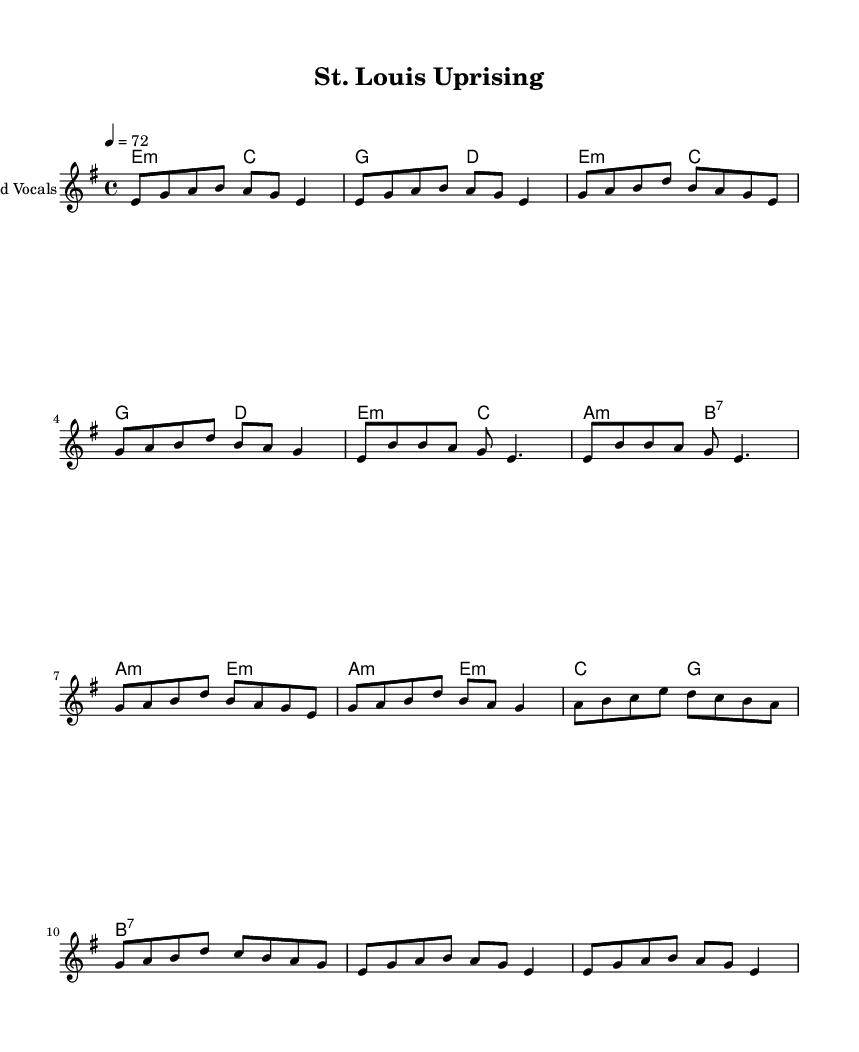What is the key signature of this music? The key signature is E minor, which has one sharp (F#) and is indicated at the beginning of the staff.
Answer: E minor What is the time signature of this music? The time signature is 4/4, meaning there are four beats per measure, indicated at the beginning of the score.
Answer: 4/4 What is the tempo of the piece? The tempo is marked as 72 beats per minute, which is indicated within the score after the time signature.
Answer: 72 How many measures are there in the verse section? The verse section contains four measures, as each line of music corresponds to a measure in the score.
Answer: Four What chords are used in the chorus? The chords used in the chorus are E minor, C, G, and D, as indicated in the chord mode section of the score.
Answer: E minor, C, G, D What type of music is this? This music is classified as conscious reggae, which specifically addresses social issues. This is inferred from the context of the title and likely themes in the lyrics.
Answer: Conscious reggae What is the function of the bridge in this structure? The bridge serves as a contrasting section that typically leads back to the chorus, which can be seen as it utilizes different chords and a varied melody.
Answer: Connects and contrasts 